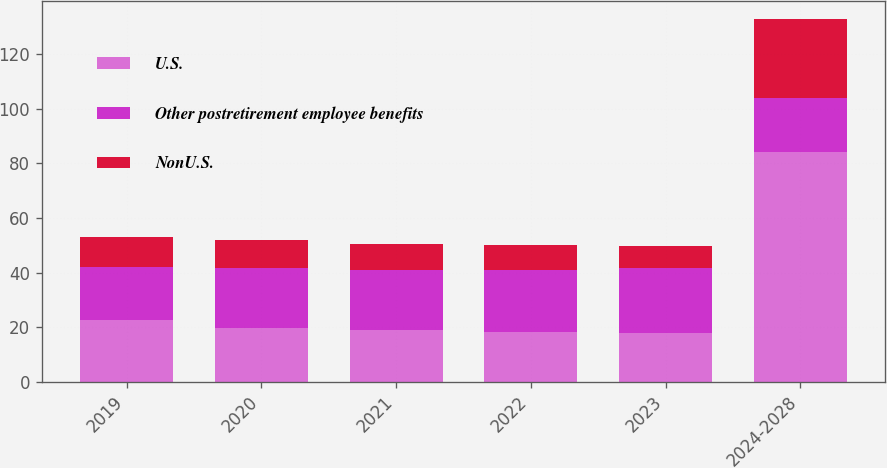<chart> <loc_0><loc_0><loc_500><loc_500><stacked_bar_chart><ecel><fcel>2019<fcel>2020<fcel>2021<fcel>2022<fcel>2023<fcel>2024-2028<nl><fcel>U.S.<fcel>22.5<fcel>19.8<fcel>18.9<fcel>18.3<fcel>17.8<fcel>84.2<nl><fcel>Other postretirement employee benefits<fcel>19.6<fcel>21.7<fcel>21.9<fcel>22.6<fcel>23.8<fcel>19.6<nl><fcel>NonU.S.<fcel>11<fcel>10.3<fcel>9.5<fcel>9.1<fcel>8<fcel>28.9<nl></chart> 